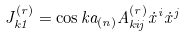Convert formula to latex. <formula><loc_0><loc_0><loc_500><loc_500>J _ { { k } 1 } ^ { ( r ) } = \cos { k a _ { ( n ) } } A _ { { k } i j } ^ { ( r ) } \dot { x } ^ { i } \dot { x } ^ { j }</formula> 